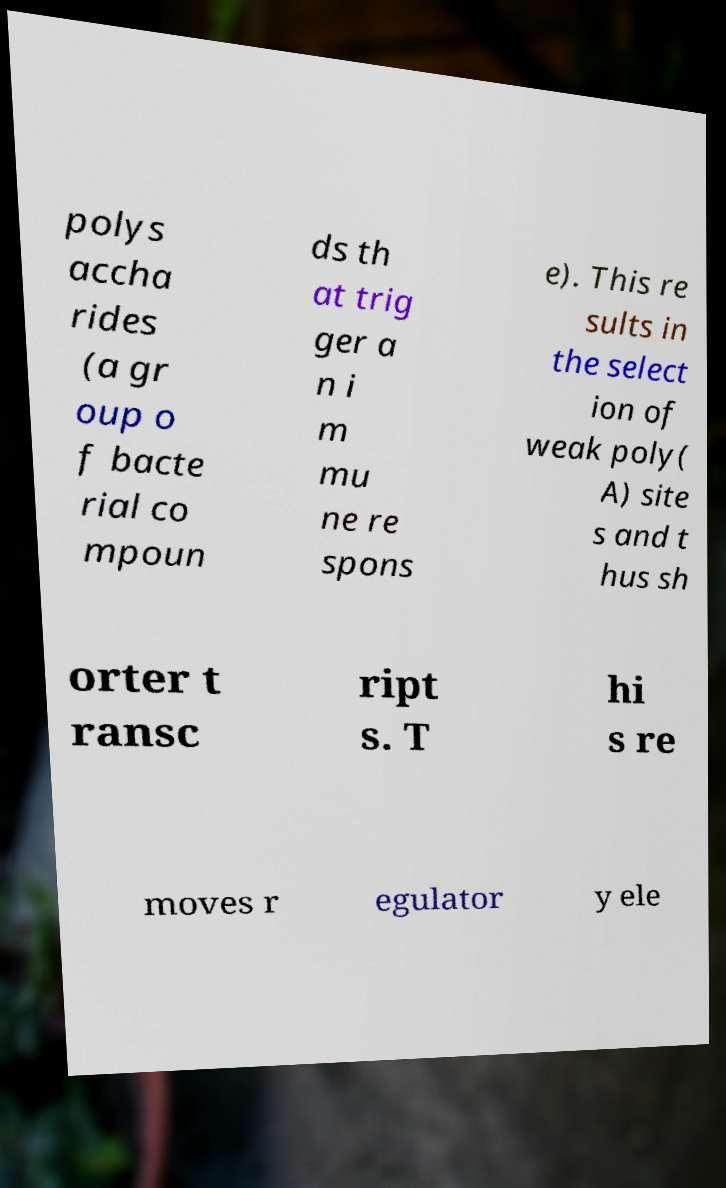For documentation purposes, I need the text within this image transcribed. Could you provide that? polys accha rides (a gr oup o f bacte rial co mpoun ds th at trig ger a n i m mu ne re spons e). This re sults in the select ion of weak poly( A) site s and t hus sh orter t ransc ript s. T hi s re moves r egulator y ele 